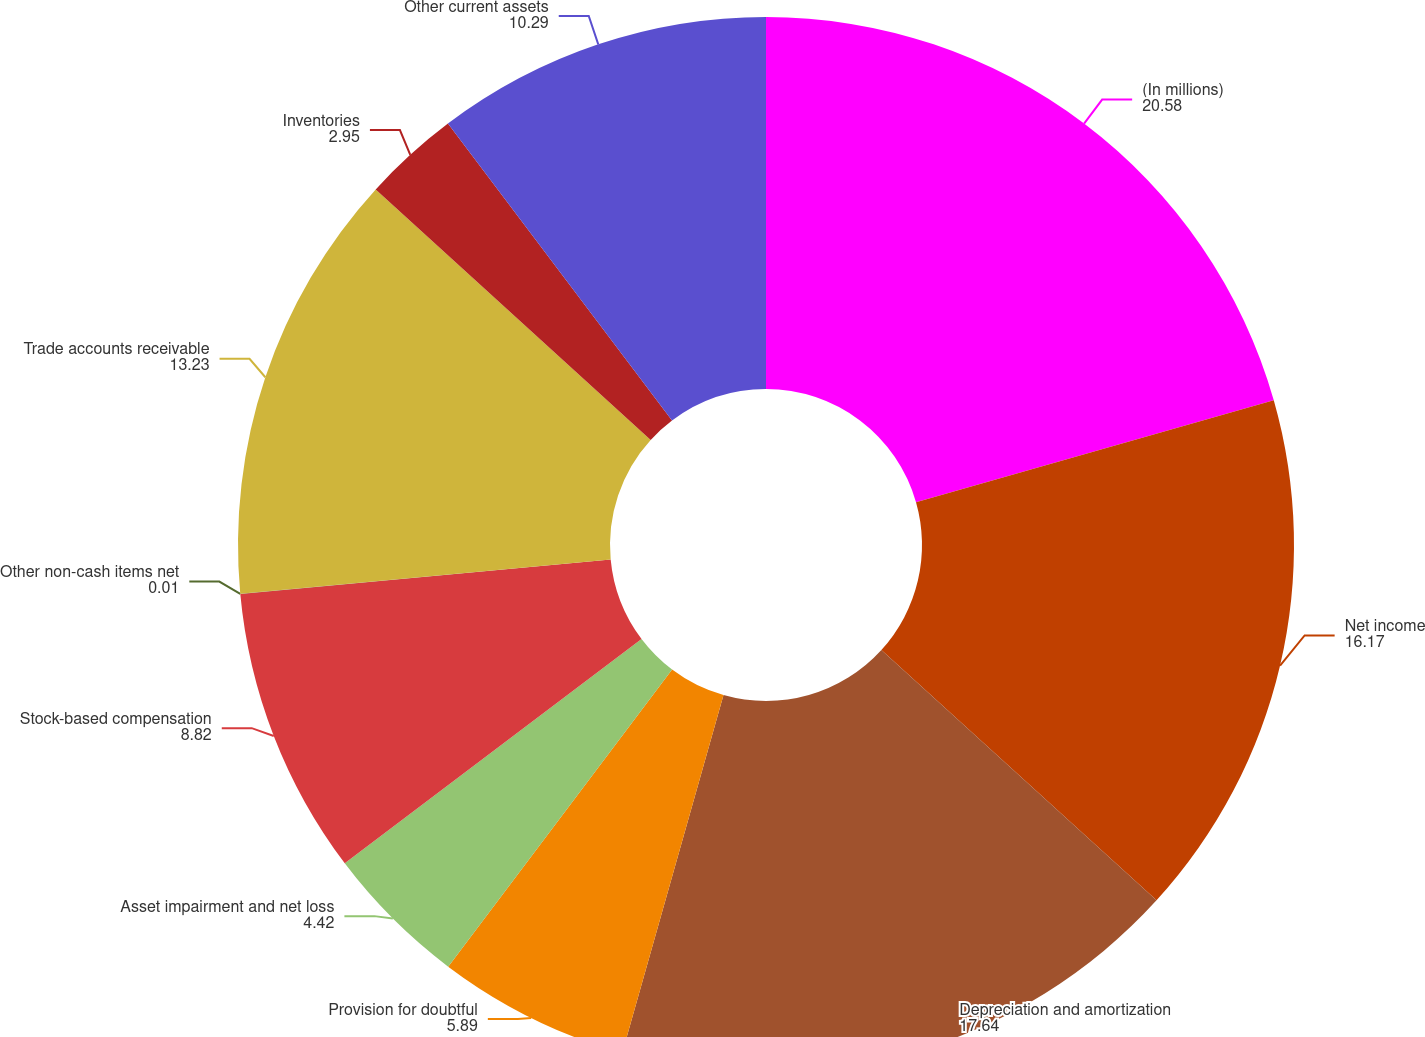Convert chart to OTSL. <chart><loc_0><loc_0><loc_500><loc_500><pie_chart><fcel>(In millions)<fcel>Net income<fcel>Depreciation and amortization<fcel>Provision for doubtful<fcel>Asset impairment and net loss<fcel>Stock-based compensation<fcel>Other non-cash items net<fcel>Trade accounts receivable<fcel>Inventories<fcel>Other current assets<nl><fcel>20.58%<fcel>16.17%<fcel>17.64%<fcel>5.89%<fcel>4.42%<fcel>8.82%<fcel>0.01%<fcel>13.23%<fcel>2.95%<fcel>10.29%<nl></chart> 